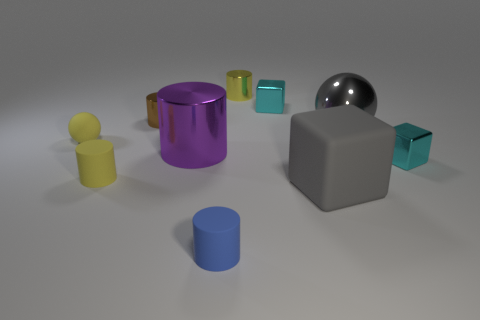Subtract all yellow cylinders. How many cylinders are left? 3 Subtract all gray matte blocks. How many blocks are left? 2 Subtract all balls. How many objects are left? 8 Subtract 3 cubes. How many cubes are left? 0 Subtract all shiny blocks. Subtract all tiny matte spheres. How many objects are left? 7 Add 2 tiny brown shiny cylinders. How many tiny brown shiny cylinders are left? 3 Add 8 big gray metal blocks. How many big gray metal blocks exist? 8 Subtract 2 cyan cubes. How many objects are left? 8 Subtract all blue spheres. Subtract all blue blocks. How many spheres are left? 2 Subtract all blue cylinders. How many gray spheres are left? 1 